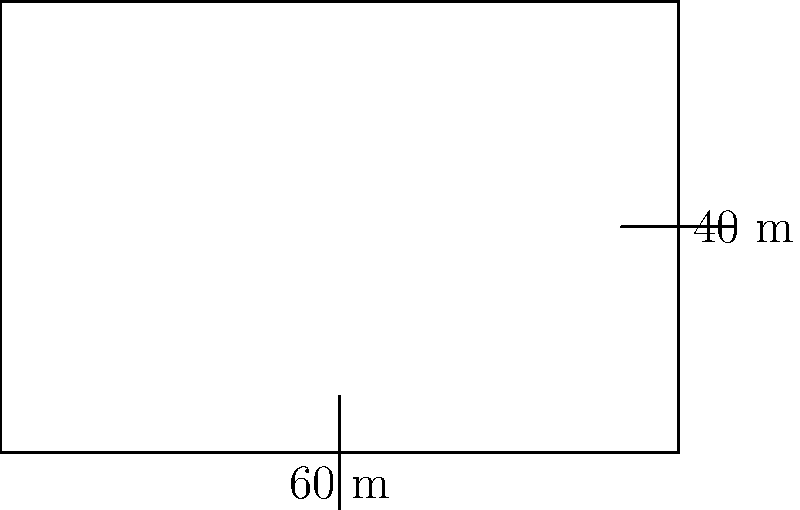A nomadic herder wants to build a rectangular horse corral on the Mongolian steppe. The corral measures 60 meters in length and 40 meters in width. What is the perimeter of the corral? To calculate the perimeter of a rectangular shape, we need to add up the lengths of all four sides. In this case:

1. The length of the corral is 60 meters.
2. The width of the corral is 40 meters.

The formula for the perimeter of a rectangle is:

$$ P = 2l + 2w $$

Where:
$P$ = perimeter
$l$ = length
$w$ = width

Let's substitute the values:

$$ P = 2(60) + 2(40) $$
$$ P = 120 + 80 $$
$$ P = 200 $$

Therefore, the perimeter of the horse corral is 200 meters.
Answer: 200 meters 